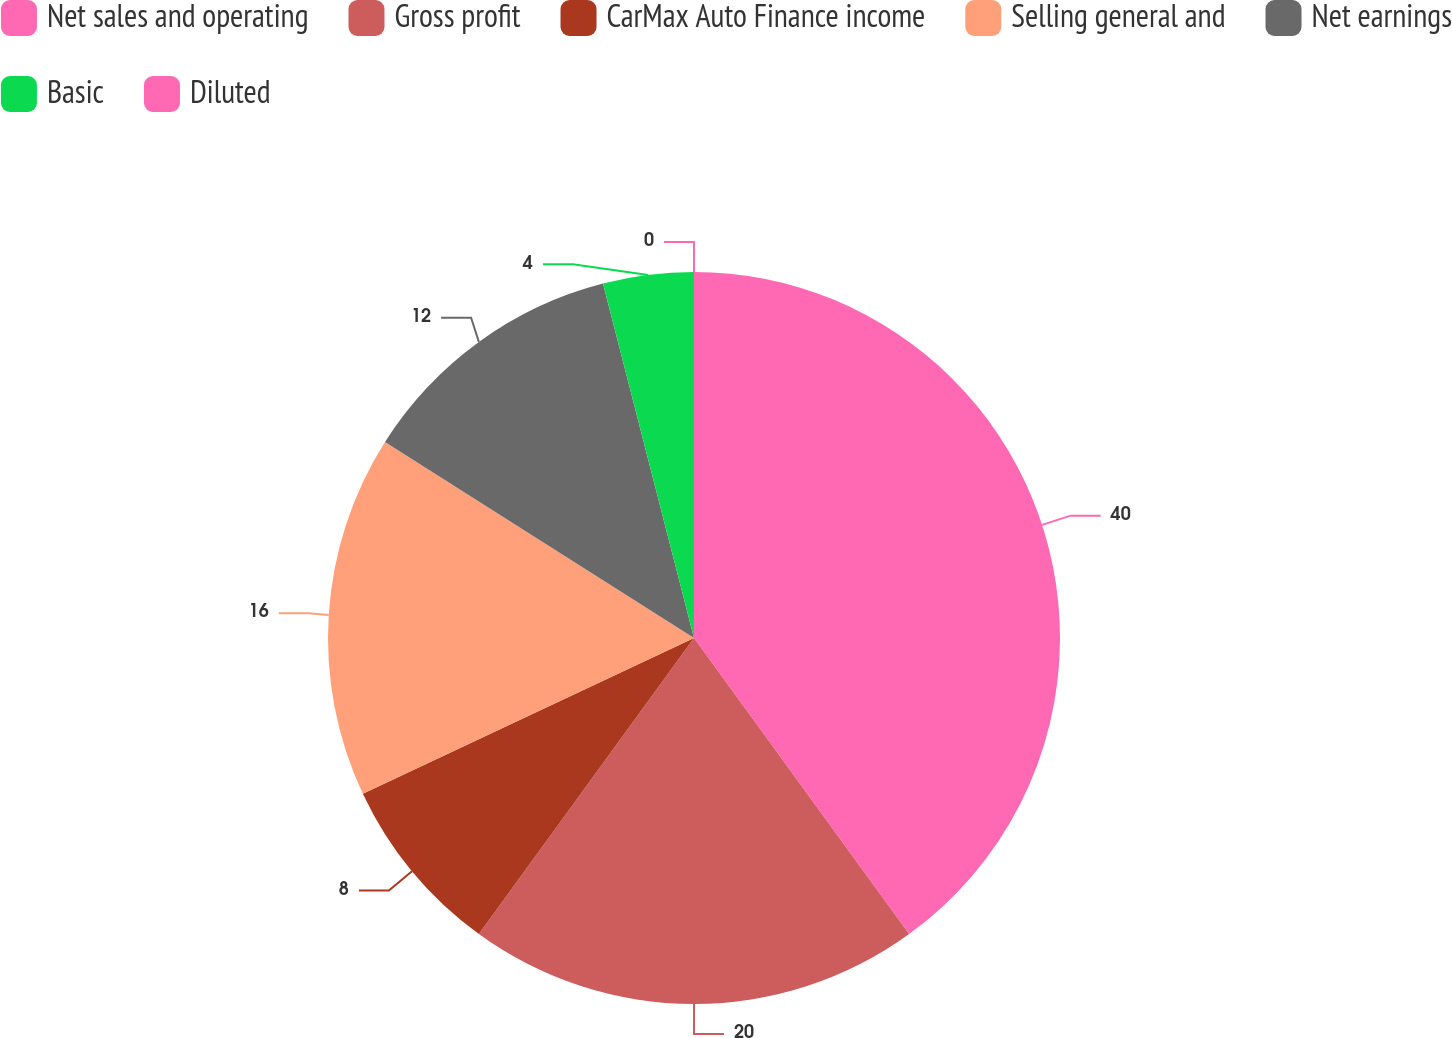Convert chart. <chart><loc_0><loc_0><loc_500><loc_500><pie_chart><fcel>Net sales and operating<fcel>Gross profit<fcel>CarMax Auto Finance income<fcel>Selling general and<fcel>Net earnings<fcel>Basic<fcel>Diluted<nl><fcel>40.0%<fcel>20.0%<fcel>8.0%<fcel>16.0%<fcel>12.0%<fcel>4.0%<fcel>0.0%<nl></chart> 